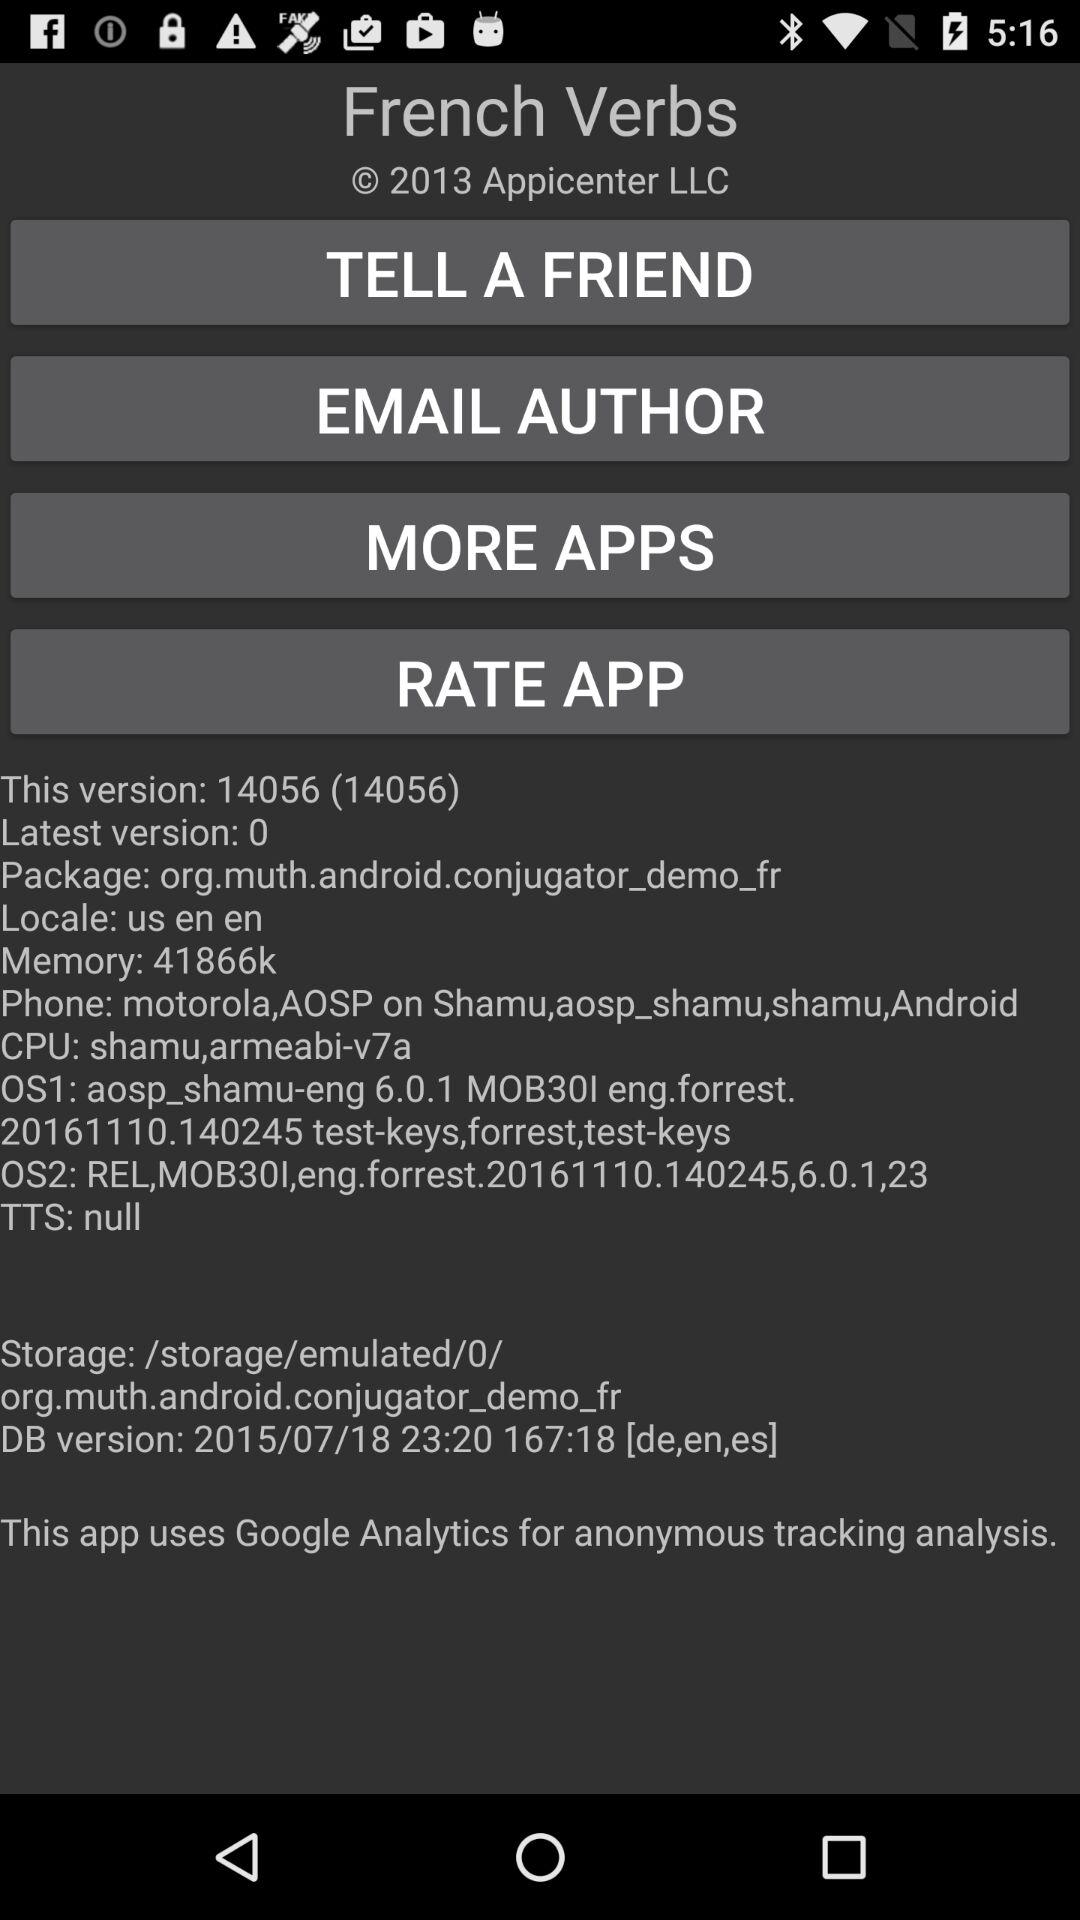What's the CPU? The CPU is "shamu,armeabi-v7a". 